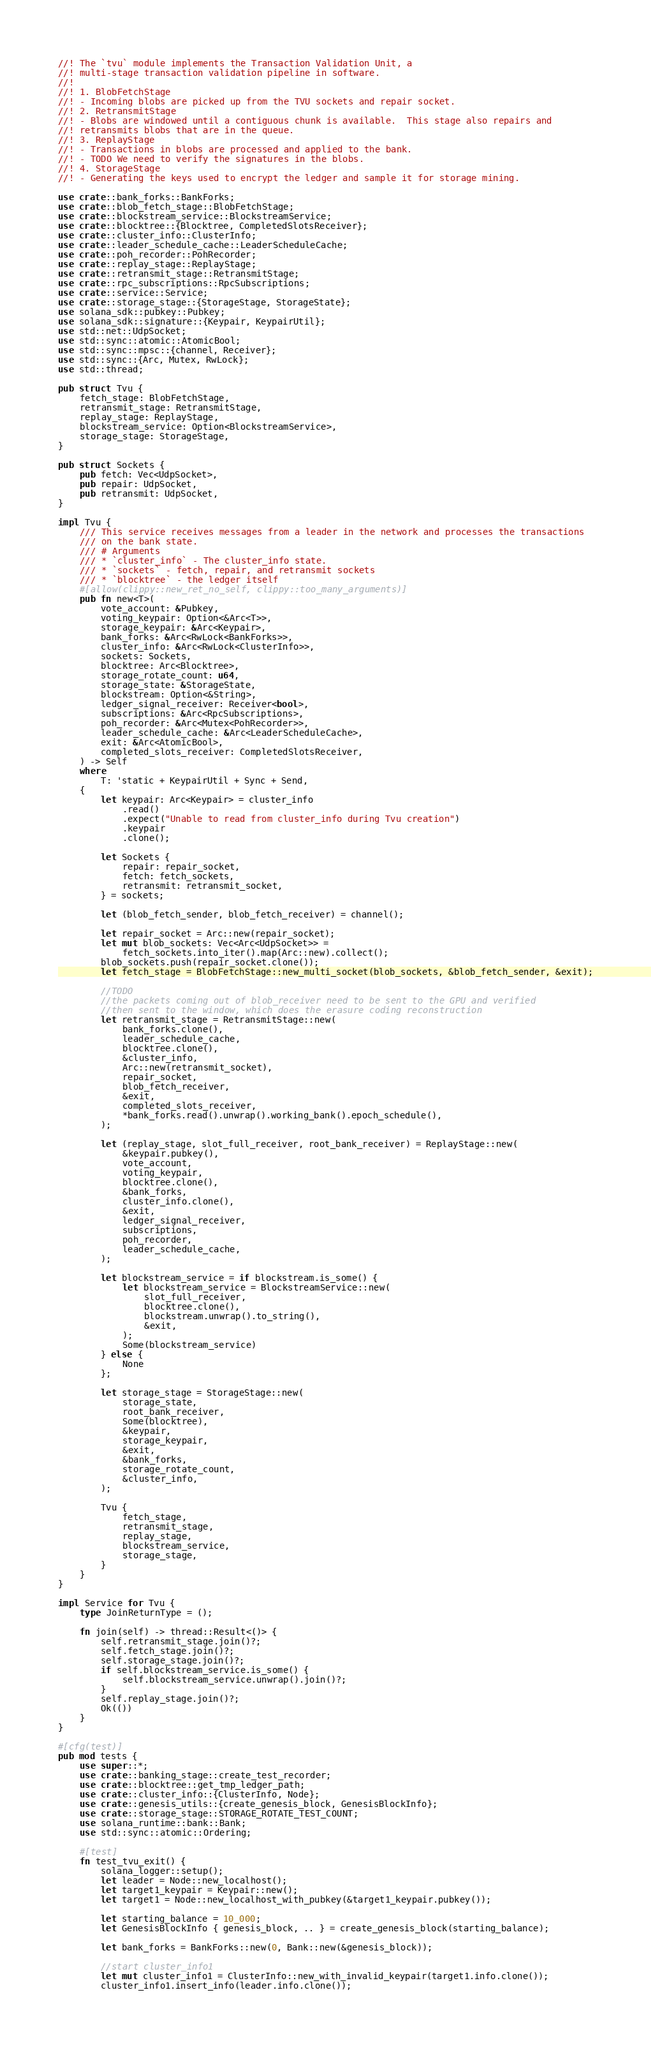Convert code to text. <code><loc_0><loc_0><loc_500><loc_500><_Rust_>//! The `tvu` module implements the Transaction Validation Unit, a
//! multi-stage transaction validation pipeline in software.
//!
//! 1. BlobFetchStage
//! - Incoming blobs are picked up from the TVU sockets and repair socket.
//! 2. RetransmitStage
//! - Blobs are windowed until a contiguous chunk is available.  This stage also repairs and
//! retransmits blobs that are in the queue.
//! 3. ReplayStage
//! - Transactions in blobs are processed and applied to the bank.
//! - TODO We need to verify the signatures in the blobs.
//! 4. StorageStage
//! - Generating the keys used to encrypt the ledger and sample it for storage mining.

use crate::bank_forks::BankForks;
use crate::blob_fetch_stage::BlobFetchStage;
use crate::blockstream_service::BlockstreamService;
use crate::blocktree::{Blocktree, CompletedSlotsReceiver};
use crate::cluster_info::ClusterInfo;
use crate::leader_schedule_cache::LeaderScheduleCache;
use crate::poh_recorder::PohRecorder;
use crate::replay_stage::ReplayStage;
use crate::retransmit_stage::RetransmitStage;
use crate::rpc_subscriptions::RpcSubscriptions;
use crate::service::Service;
use crate::storage_stage::{StorageStage, StorageState};
use solana_sdk::pubkey::Pubkey;
use solana_sdk::signature::{Keypair, KeypairUtil};
use std::net::UdpSocket;
use std::sync::atomic::AtomicBool;
use std::sync::mpsc::{channel, Receiver};
use std::sync::{Arc, Mutex, RwLock};
use std::thread;

pub struct Tvu {
    fetch_stage: BlobFetchStage,
    retransmit_stage: RetransmitStage,
    replay_stage: ReplayStage,
    blockstream_service: Option<BlockstreamService>,
    storage_stage: StorageStage,
}

pub struct Sockets {
    pub fetch: Vec<UdpSocket>,
    pub repair: UdpSocket,
    pub retransmit: UdpSocket,
}

impl Tvu {
    /// This service receives messages from a leader in the network and processes the transactions
    /// on the bank state.
    /// # Arguments
    /// * `cluster_info` - The cluster_info state.
    /// * `sockets` - fetch, repair, and retransmit sockets
    /// * `blocktree` - the ledger itself
    #[allow(clippy::new_ret_no_self, clippy::too_many_arguments)]
    pub fn new<T>(
        vote_account: &Pubkey,
        voting_keypair: Option<&Arc<T>>,
        storage_keypair: &Arc<Keypair>,
        bank_forks: &Arc<RwLock<BankForks>>,
        cluster_info: &Arc<RwLock<ClusterInfo>>,
        sockets: Sockets,
        blocktree: Arc<Blocktree>,
        storage_rotate_count: u64,
        storage_state: &StorageState,
        blockstream: Option<&String>,
        ledger_signal_receiver: Receiver<bool>,
        subscriptions: &Arc<RpcSubscriptions>,
        poh_recorder: &Arc<Mutex<PohRecorder>>,
        leader_schedule_cache: &Arc<LeaderScheduleCache>,
        exit: &Arc<AtomicBool>,
        completed_slots_receiver: CompletedSlotsReceiver,
    ) -> Self
    where
        T: 'static + KeypairUtil + Sync + Send,
    {
        let keypair: Arc<Keypair> = cluster_info
            .read()
            .expect("Unable to read from cluster_info during Tvu creation")
            .keypair
            .clone();

        let Sockets {
            repair: repair_socket,
            fetch: fetch_sockets,
            retransmit: retransmit_socket,
        } = sockets;

        let (blob_fetch_sender, blob_fetch_receiver) = channel();

        let repair_socket = Arc::new(repair_socket);
        let mut blob_sockets: Vec<Arc<UdpSocket>> =
            fetch_sockets.into_iter().map(Arc::new).collect();
        blob_sockets.push(repair_socket.clone());
        let fetch_stage = BlobFetchStage::new_multi_socket(blob_sockets, &blob_fetch_sender, &exit);

        //TODO
        //the packets coming out of blob_receiver need to be sent to the GPU and verified
        //then sent to the window, which does the erasure coding reconstruction
        let retransmit_stage = RetransmitStage::new(
            bank_forks.clone(),
            leader_schedule_cache,
            blocktree.clone(),
            &cluster_info,
            Arc::new(retransmit_socket),
            repair_socket,
            blob_fetch_receiver,
            &exit,
            completed_slots_receiver,
            *bank_forks.read().unwrap().working_bank().epoch_schedule(),
        );

        let (replay_stage, slot_full_receiver, root_bank_receiver) = ReplayStage::new(
            &keypair.pubkey(),
            vote_account,
            voting_keypair,
            blocktree.clone(),
            &bank_forks,
            cluster_info.clone(),
            &exit,
            ledger_signal_receiver,
            subscriptions,
            poh_recorder,
            leader_schedule_cache,
        );

        let blockstream_service = if blockstream.is_some() {
            let blockstream_service = BlockstreamService::new(
                slot_full_receiver,
                blocktree.clone(),
                blockstream.unwrap().to_string(),
                &exit,
            );
            Some(blockstream_service)
        } else {
            None
        };

        let storage_stage = StorageStage::new(
            storage_state,
            root_bank_receiver,
            Some(blocktree),
            &keypair,
            storage_keypair,
            &exit,
            &bank_forks,
            storage_rotate_count,
            &cluster_info,
        );

        Tvu {
            fetch_stage,
            retransmit_stage,
            replay_stage,
            blockstream_service,
            storage_stage,
        }
    }
}

impl Service for Tvu {
    type JoinReturnType = ();

    fn join(self) -> thread::Result<()> {
        self.retransmit_stage.join()?;
        self.fetch_stage.join()?;
        self.storage_stage.join()?;
        if self.blockstream_service.is_some() {
            self.blockstream_service.unwrap().join()?;
        }
        self.replay_stage.join()?;
        Ok(())
    }
}

#[cfg(test)]
pub mod tests {
    use super::*;
    use crate::banking_stage::create_test_recorder;
    use crate::blocktree::get_tmp_ledger_path;
    use crate::cluster_info::{ClusterInfo, Node};
    use crate::genesis_utils::{create_genesis_block, GenesisBlockInfo};
    use crate::storage_stage::STORAGE_ROTATE_TEST_COUNT;
    use solana_runtime::bank::Bank;
    use std::sync::atomic::Ordering;

    #[test]
    fn test_tvu_exit() {
        solana_logger::setup();
        let leader = Node::new_localhost();
        let target1_keypair = Keypair::new();
        let target1 = Node::new_localhost_with_pubkey(&target1_keypair.pubkey());

        let starting_balance = 10_000;
        let GenesisBlockInfo { genesis_block, .. } = create_genesis_block(starting_balance);

        let bank_forks = BankForks::new(0, Bank::new(&genesis_block));

        //start cluster_info1
        let mut cluster_info1 = ClusterInfo::new_with_invalid_keypair(target1.info.clone());
        cluster_info1.insert_info(leader.info.clone());</code> 